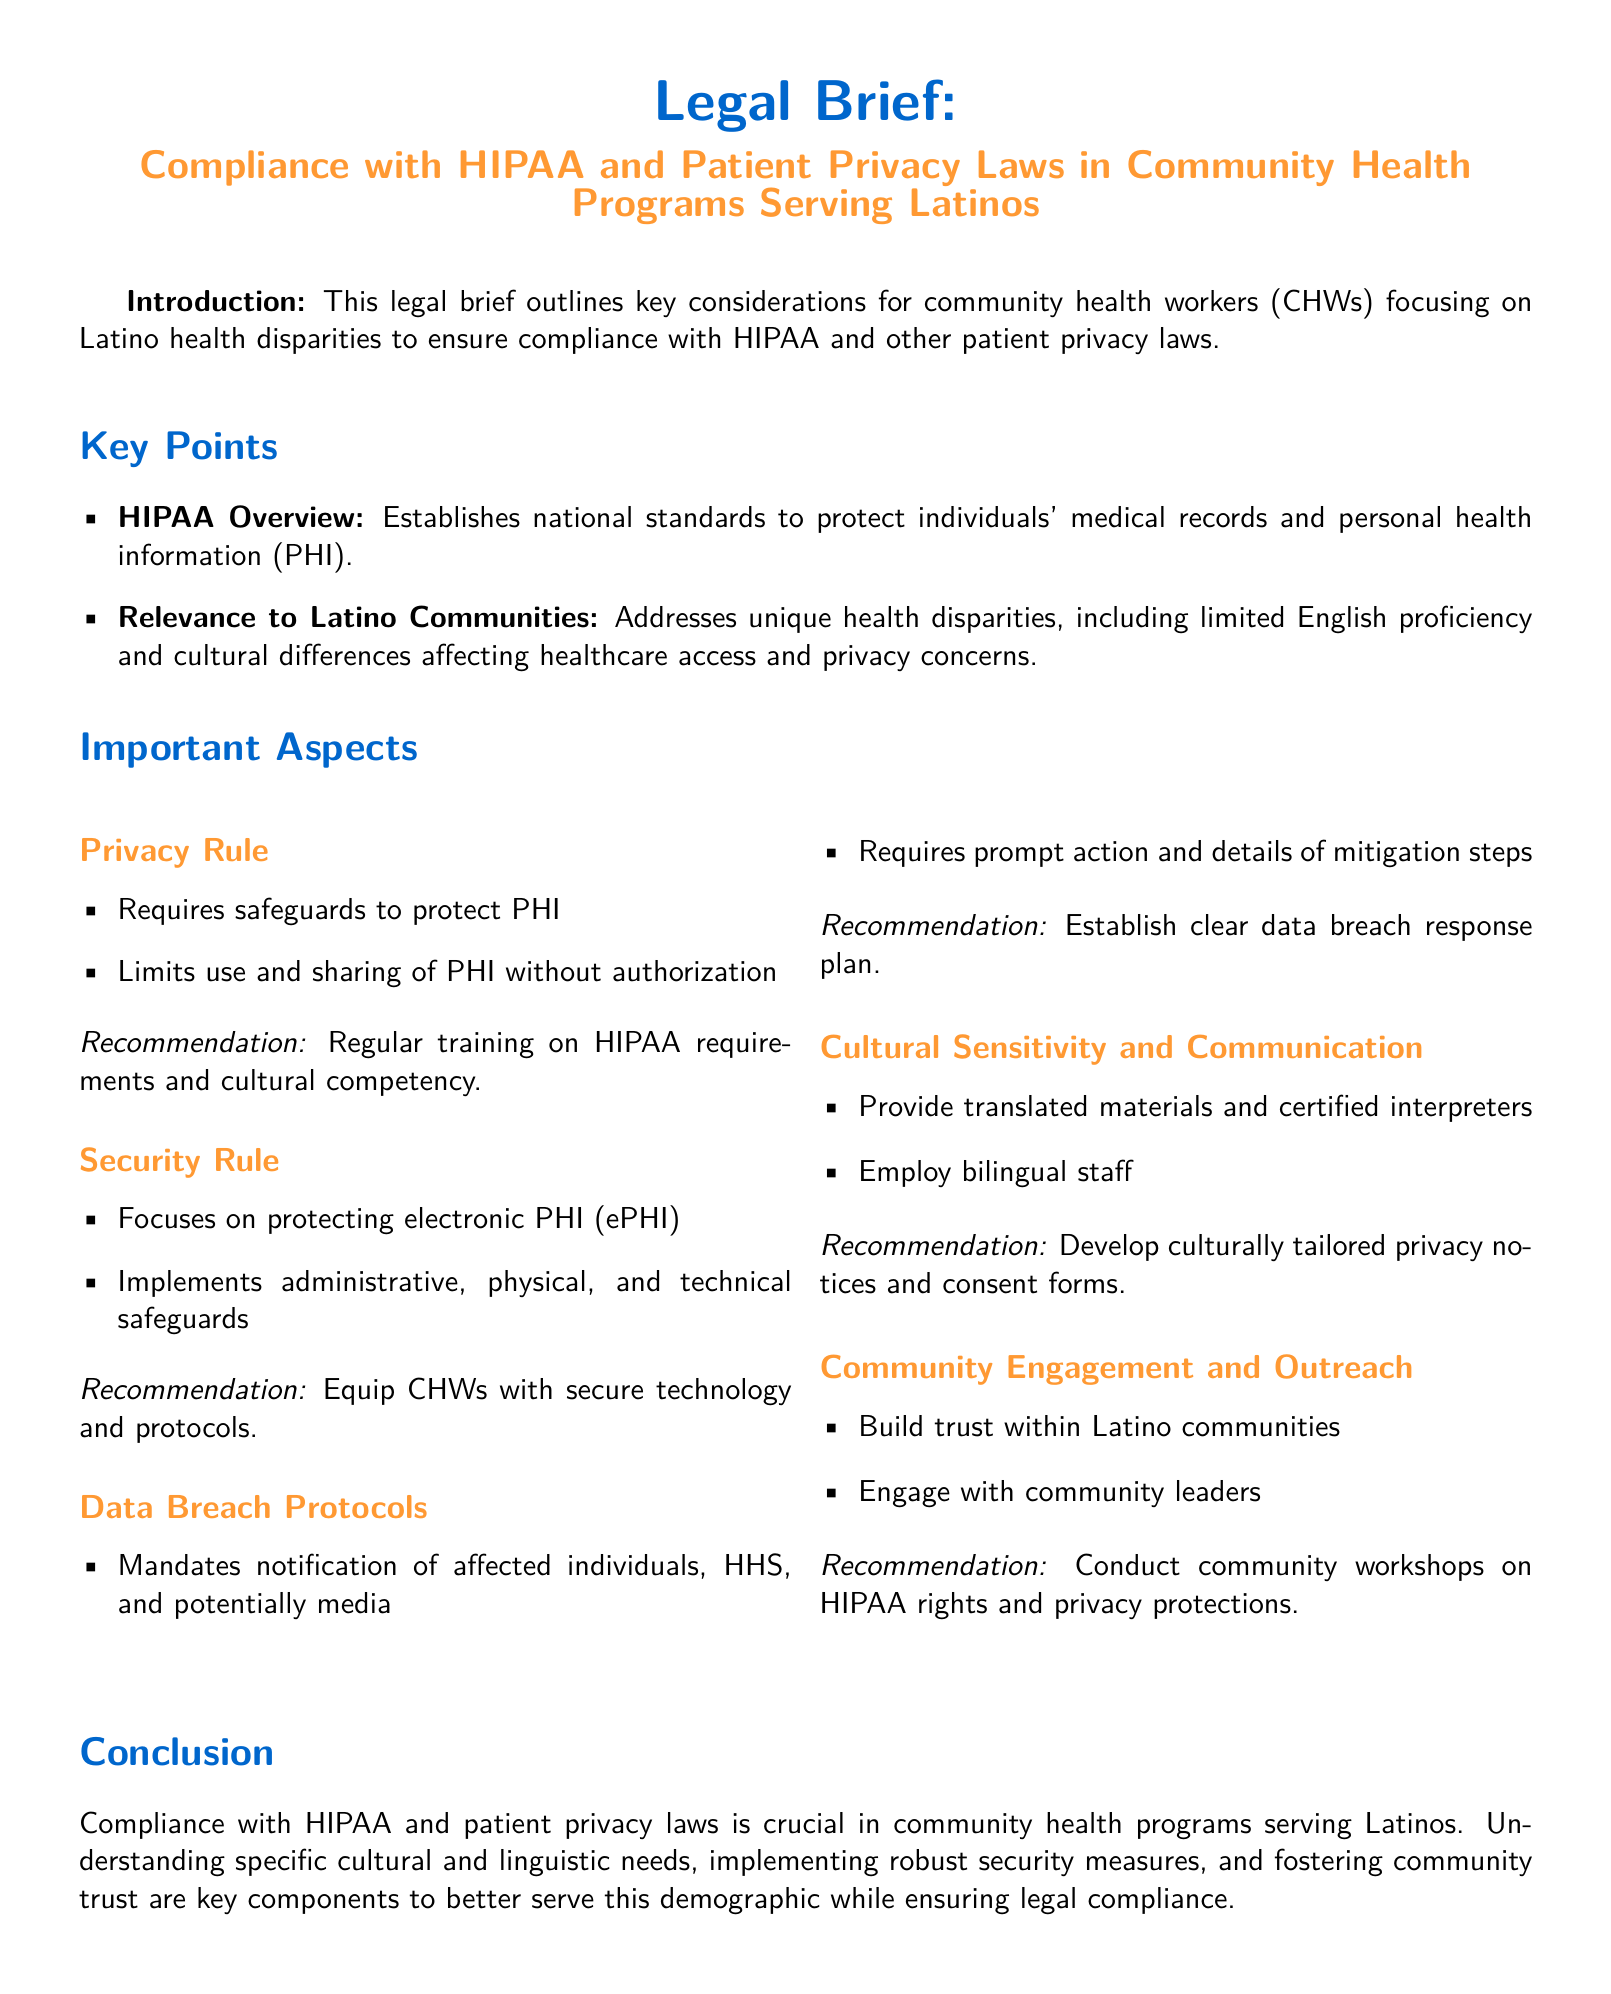What does HIPAA stand for? HIPAA stands for Health Insurance Portability and Accountability Act, as referenced in the document.
Answer: Health Insurance Portability and Accountability Act What is the focus of the Security Rule? The Security Rule focuses on protecting electronic PHI (ePHI), which is stated in the document.
Answer: Protecting electronic PHI What is a recommendation for safeguarding PHI? The document recommends regular training on HIPAA requirements and cultural competency.
Answer: Regular training on HIPAA requirements and cultural competency How many recommendations are provided under Data Breach Protocols? The document lists one main recommendation for establishing a clear data breach response plan under Data Breach Protocols.
Answer: One What is one aspect that the Privacy Rule addresses? The Privacy Rule addresses the requirement for safeguards to protect PHI, as outlined in the document.
Answer: Safeguards to protect PHI Why is community engagement important for Latino health programs? The document states that building trust within Latino communities is essential, reflecting the need for community engagement.
Answer: Building trust within Latino communities What type of materials should be provided according to the cultural sensitivity recommendations? The document mentions providing translated materials as part of the cultural sensitivity recommendations.
Answer: Translated materials Which group should be engaged with according to the Community Engagement section? Community leaders should be engaged, as emphasized in the document.
Answer: Community leaders What color is used for the title in the document? The title uses the primary color, which is specified in the document as RGB 0,102,204.
Answer: RGB 0,102,204 